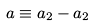<formula> <loc_0><loc_0><loc_500><loc_500>a \equiv a _ { 2 } - a _ { 2 }</formula> 